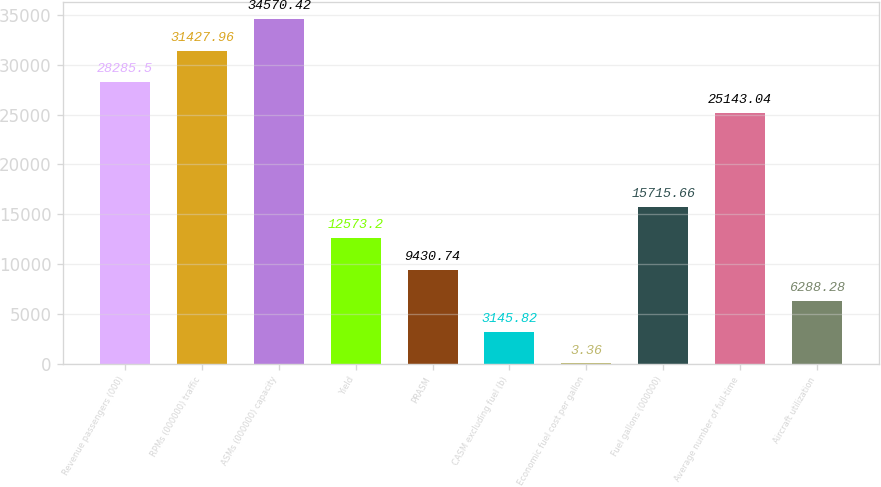<chart> <loc_0><loc_0><loc_500><loc_500><bar_chart><fcel>Revenue passengers (000)<fcel>RPMs (000000) traffic<fcel>ASMs (000000) capacity<fcel>Yield<fcel>PRASM<fcel>CASM excluding fuel (b)<fcel>Economic fuel cost per gallon<fcel>Fuel gallons (000000)<fcel>Average number of full-time<fcel>Aircraft utilization<nl><fcel>28285.5<fcel>31428<fcel>34570.4<fcel>12573.2<fcel>9430.74<fcel>3145.82<fcel>3.36<fcel>15715.7<fcel>25143<fcel>6288.28<nl></chart> 